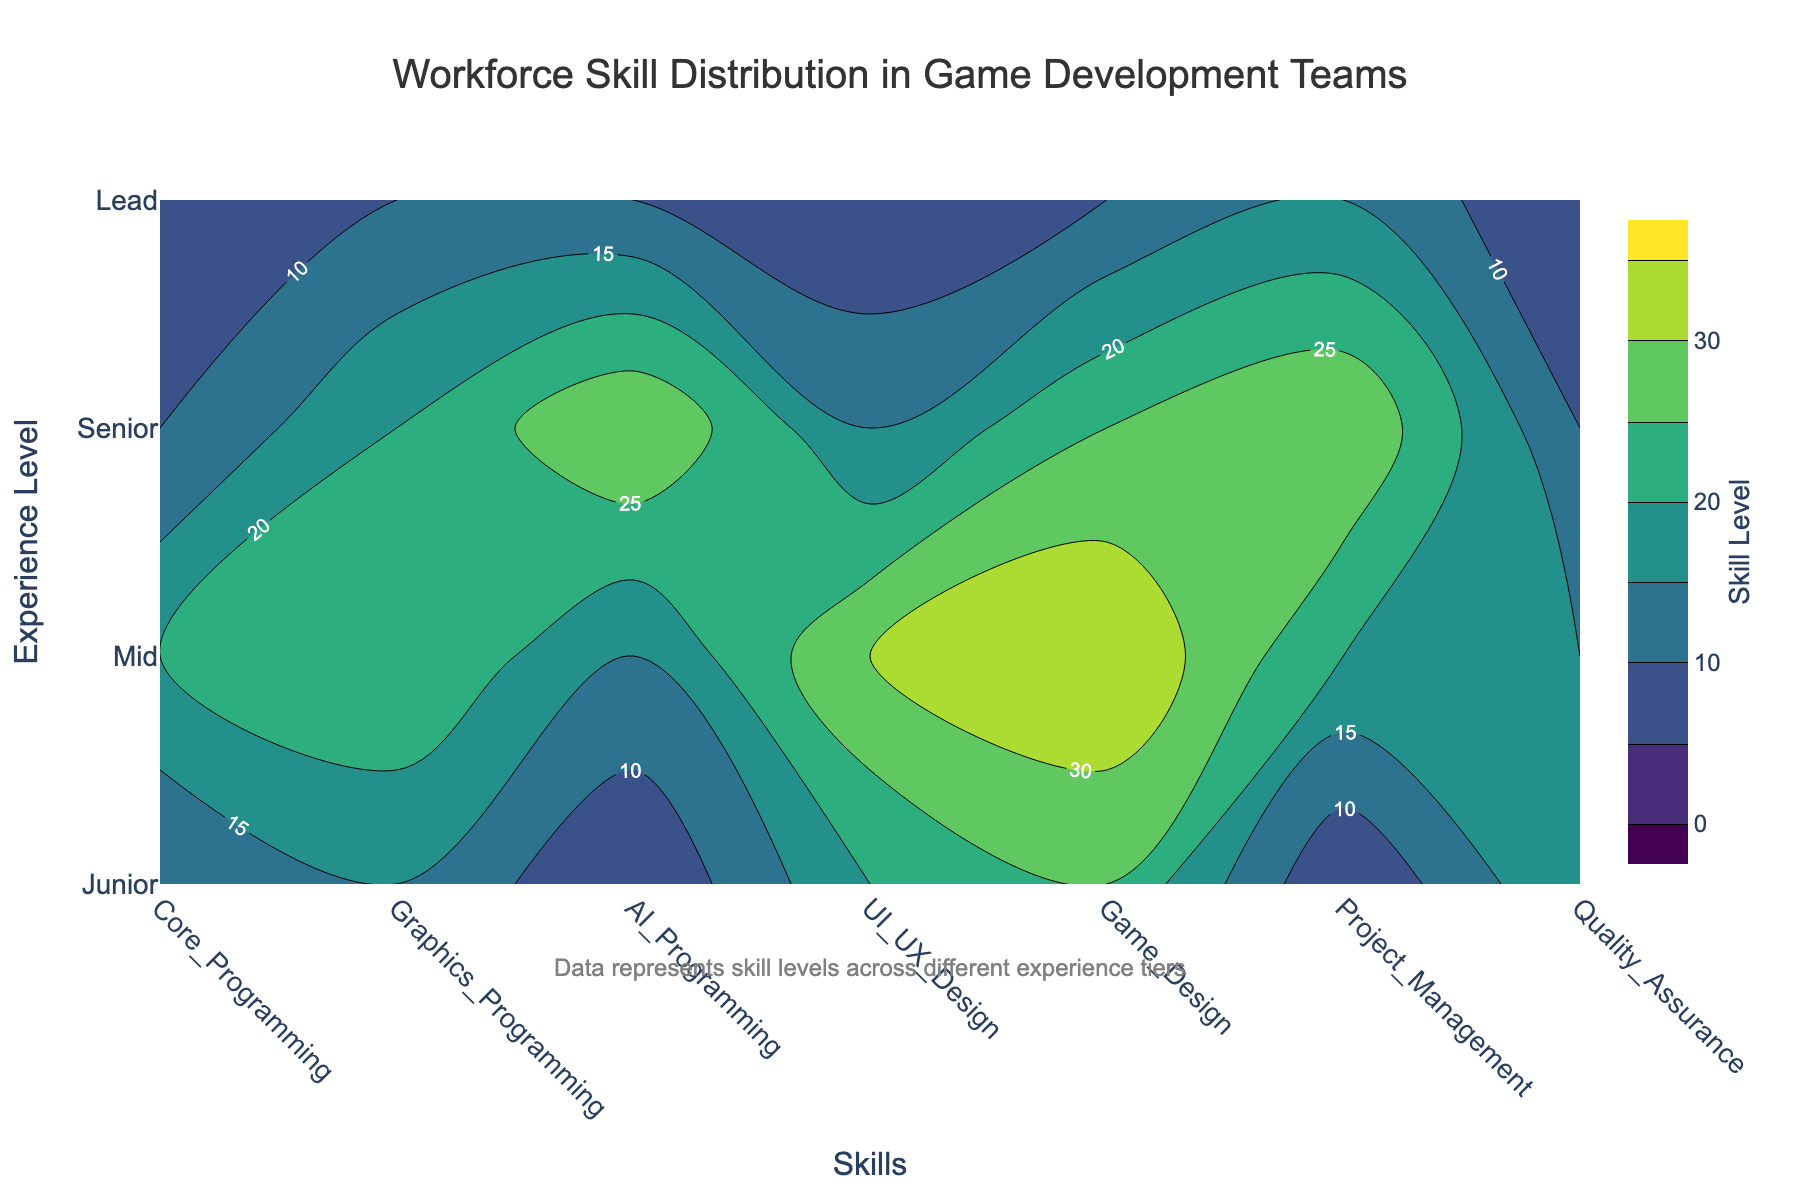What's the title of the figure? The title is centered at the top of the figure in larger font.
Answer: Workforce Skill Distribution in Game Development Teams How many experience levels are displayed in the figure? The y-axis displays the experience levels, each corresponding to rows in the data. Counting them, we see there are four levels.
Answer: 4 What skill has the highest skill level for Mid-experience employees? By looking at the contour plot along the Mid-experience row, we find the highest contour line value, which in this case is found under Game Design.
Answer: Game Design Which skill has the least representation in the Lead experience level? On the contour plot, checking the lowest values along the Lead experience row, we find the lowest value contour line at 5 in Core Programming, UI/UX Design, and Quality Assurance.
Answer: Core Programming, UI/UX Design, Quality Assurance How does the skill level of AI Programming compare between Junior and Senior experience levels? By comparing the values in the row corresponding to Junior and Senior levels under the AI Programming column, we see they are 5 and 30 respectively. Thus, Senior has a much higher level in AI Programming.
Answer: Senior has a higher skill level What's the average skill level in Project Management across all experience levels? We sum the values for Project Management across all experience levels (5+20+30+15=70) and then divide by 4 (the number of experience levels).
Answer: 17.5 Which experience level has the broadest range of skill levels across all areas? By checking the maximum and minimum skill levels across all columns for each experience level, Junior ranges from 5 to 25, Mid ranges from 15 to 35, Senior ranges from 10 to 30, and Lead ranges from 5 to 15. Mid has the broadest range (20).
Answer: Mid In which skill did all experience levels show a minimum value of 5? By checking the data values, we observe that all entries in UI/UX Design have a minimum value of 5 among all experience levels.
Answer: UI/UX Design How does the skill level distribution for Graphics Programming change from Junior to Mid levels? Comparing the values for Graphics Programming in Junior (15) and Mid (25), there is an increase of 10 units when moving from Junior to Mid experience levels.
Answer: It increases by 10 units 